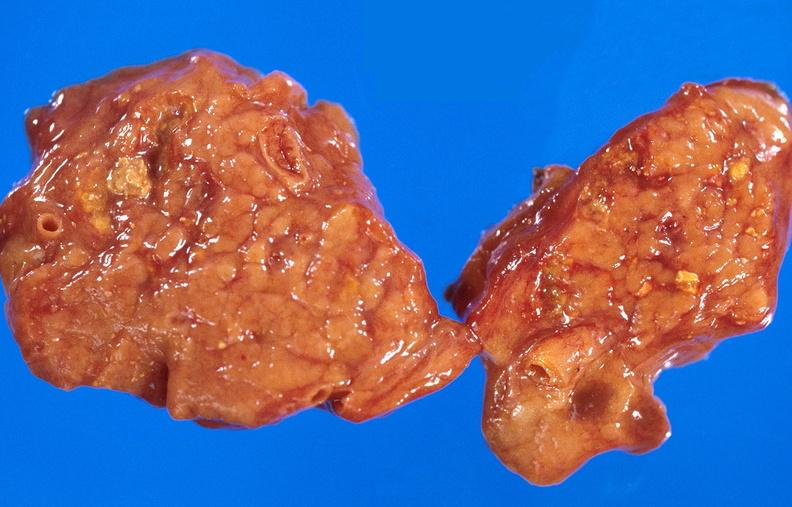does intraductal papillomatosis with apocrine metaplasia show pancreatic fat necrosis?
Answer the question using a single word or phrase. No 